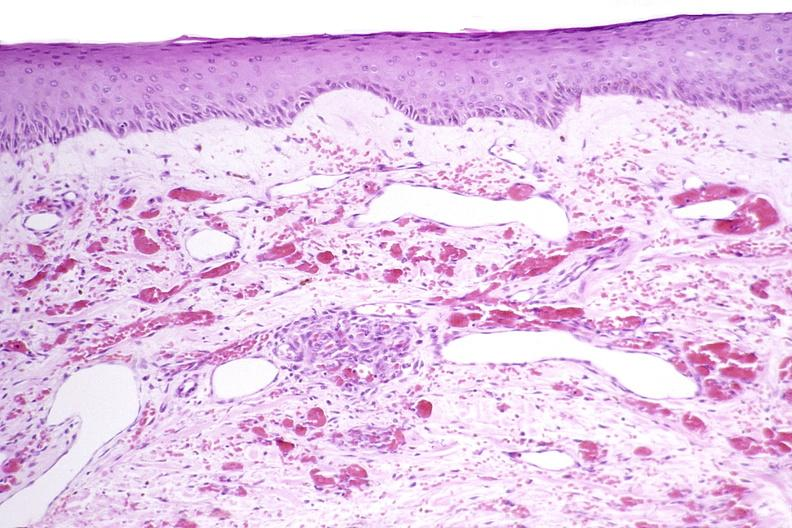does exostosis show skin, kaposis 's sarcoma?
Answer the question using a single word or phrase. No 